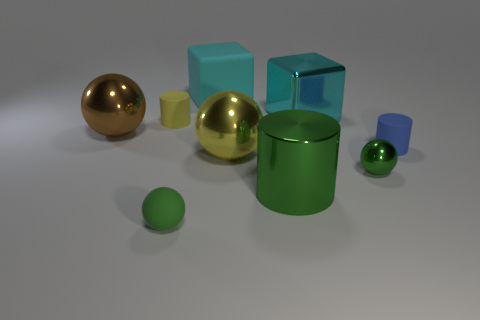Subtract all tiny matte cylinders. How many cylinders are left? 1 Subtract all green cylinders. How many cylinders are left? 2 Subtract all purple cubes. How many green spheres are left? 2 Add 1 big metal things. How many objects exist? 10 Add 7 cyan rubber blocks. How many cyan rubber blocks are left? 8 Add 9 small red metallic blocks. How many small red metallic blocks exist? 9 Subtract 0 yellow cubes. How many objects are left? 9 Subtract all spheres. How many objects are left? 5 Subtract all cyan cylinders. Subtract all yellow spheres. How many cylinders are left? 3 Subtract all matte cubes. Subtract all tiny cyan matte cylinders. How many objects are left? 8 